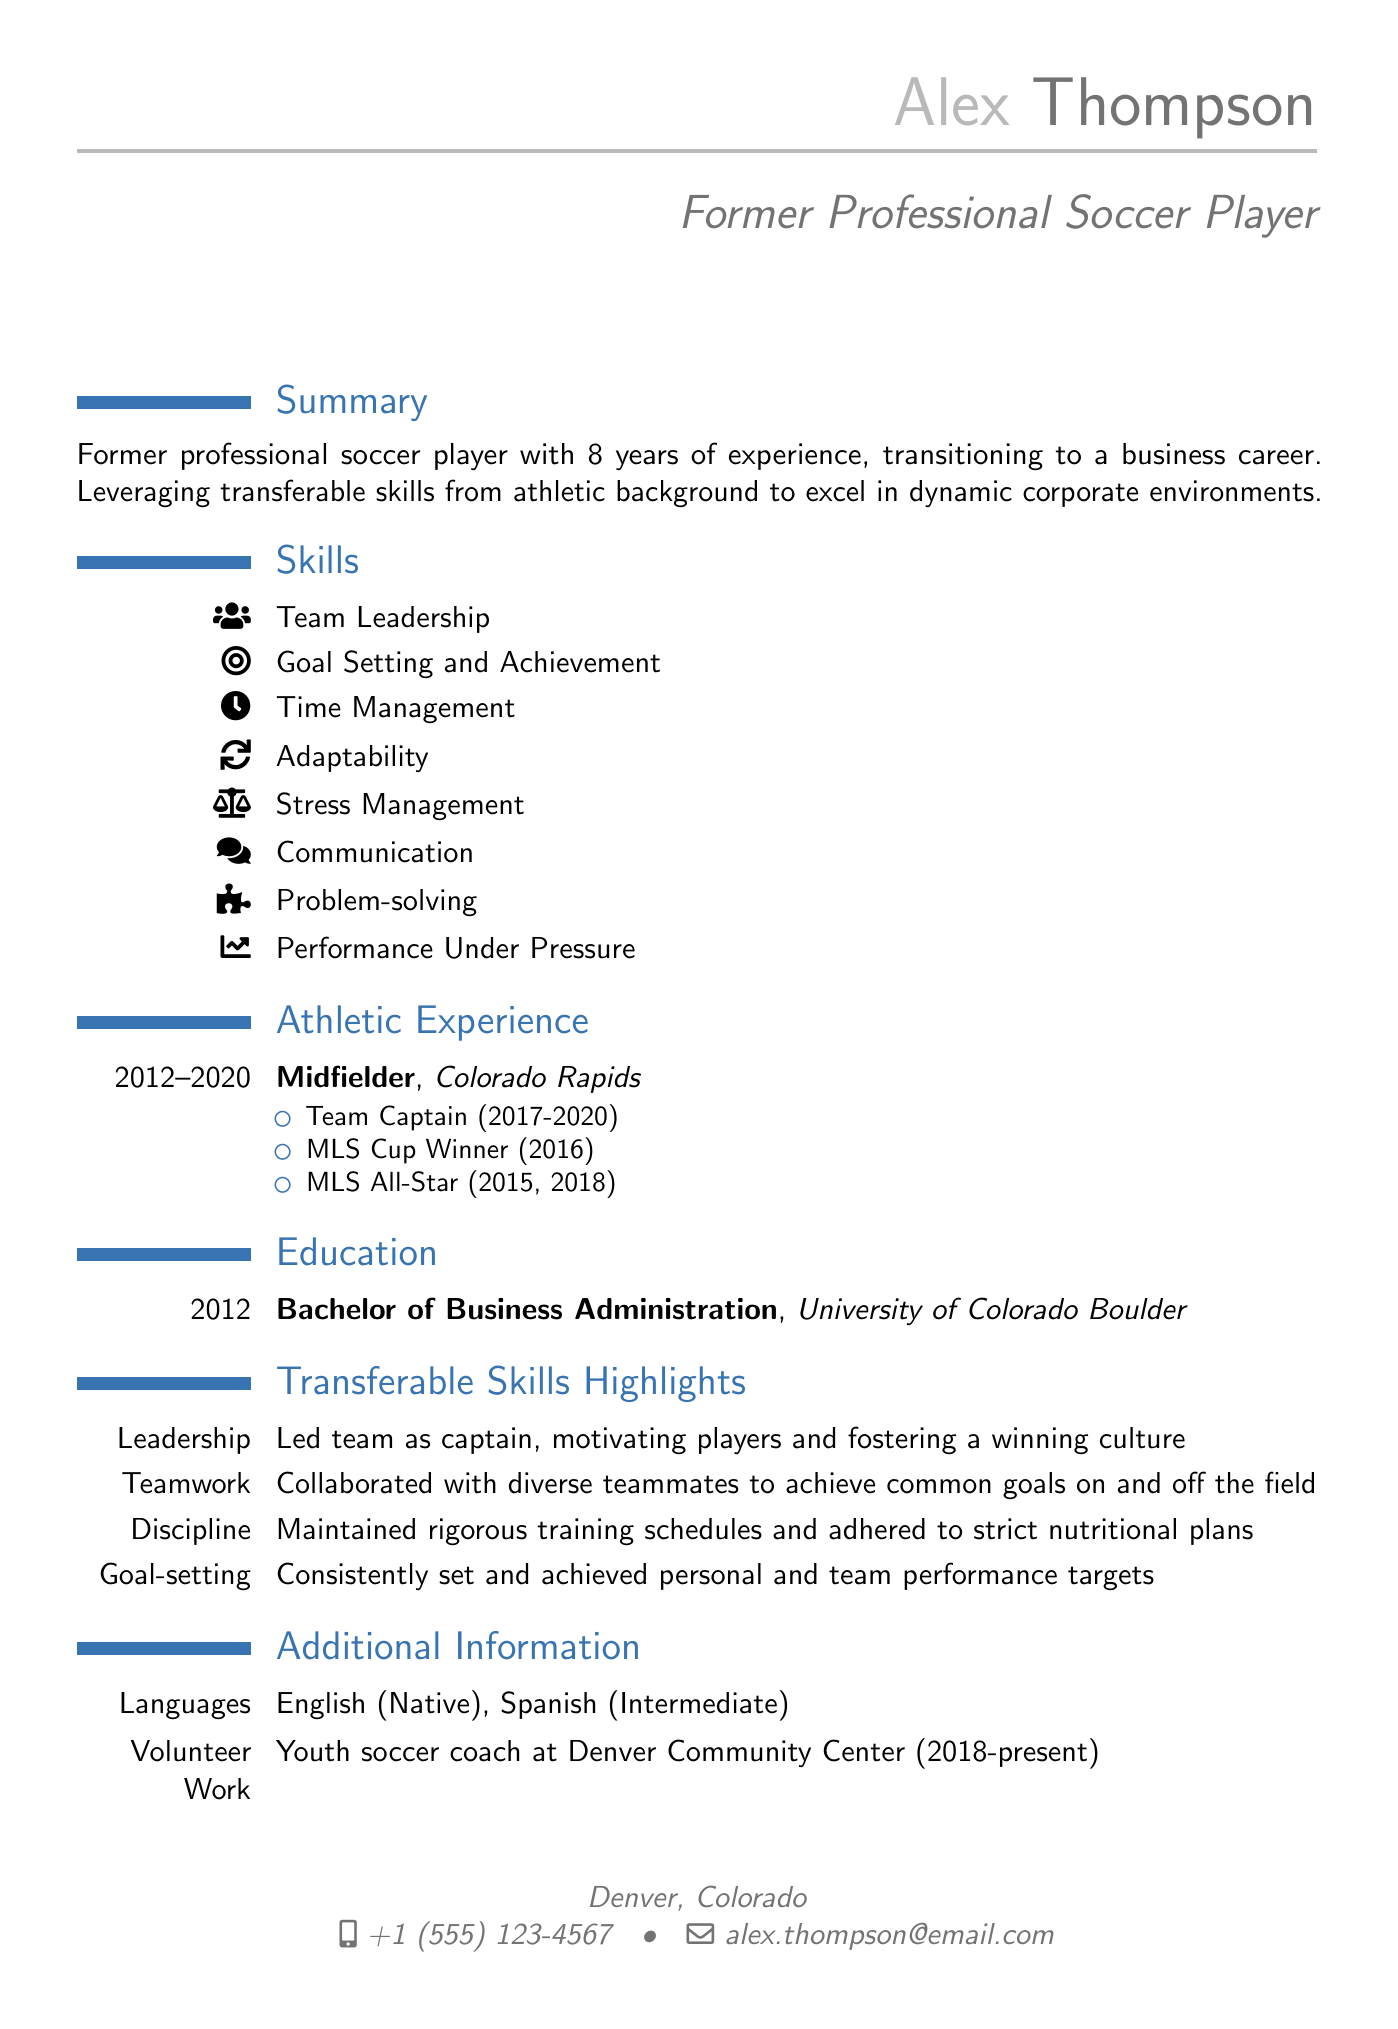what is the name of the individual? The name of the individual is mentioned in the personal information section of the document.
Answer: Alex Thompson what was the position played by Alex in the Colorado Rapids? The position can be found in the athletic experience section of the document.
Answer: Midfielder how many years of professional soccer experience does Alex have? The number of years is specified in the summary section of the document.
Answer: 8 years what degree did Alex obtain? The degree can be found in the education section of the document.
Answer: Bachelor of Business Administration which language does Alex speak at an intermediate level? The languages spoken are listed in the additional information section of the document.
Answer: Spanish what notable achievement did Alex receive in 2016? A specific achievement is mentioned under athletic experience in the document.
Answer: MLS Cup Winner how long did Alex serve as team captain? The duration of the captaincy is noted in the athletic experience section of the document.
Answer: 3 years what skill is highlighted as a key area of expertise in the CV? A specific skill is mentioned in the skills section of the document.
Answer: Team Leadership what year did Alex graduate from university? The graduation year is specified in the education section of the document.
Answer: 2012 